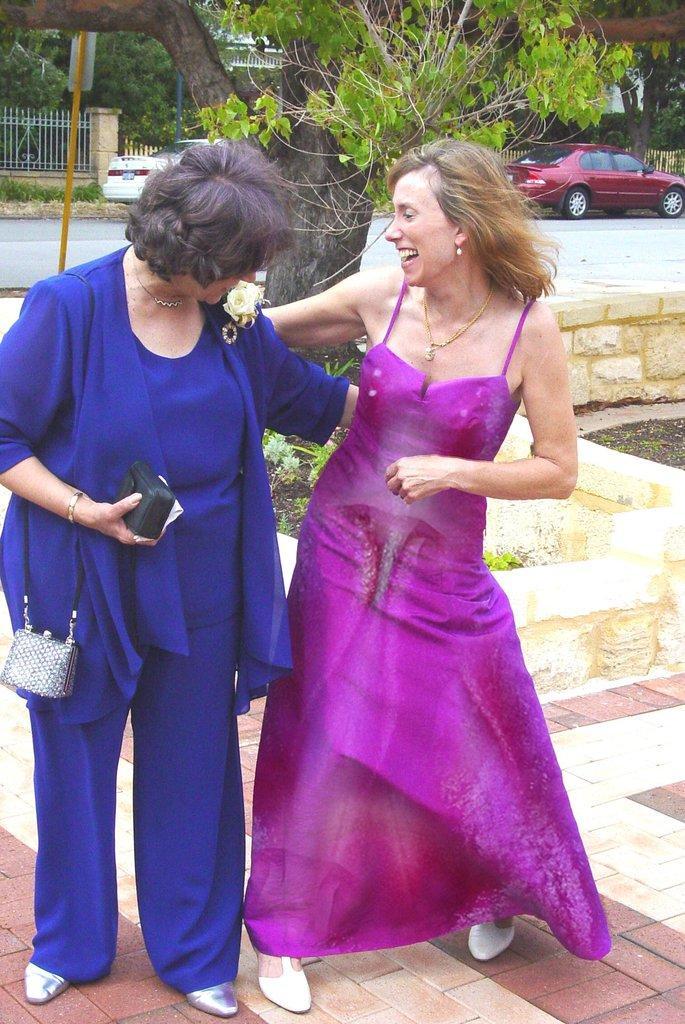In one or two sentences, can you explain what this image depicts? In the background we can see trees, fence. Here we can see cars on the road. Here we can see women standing. This is a bag. 